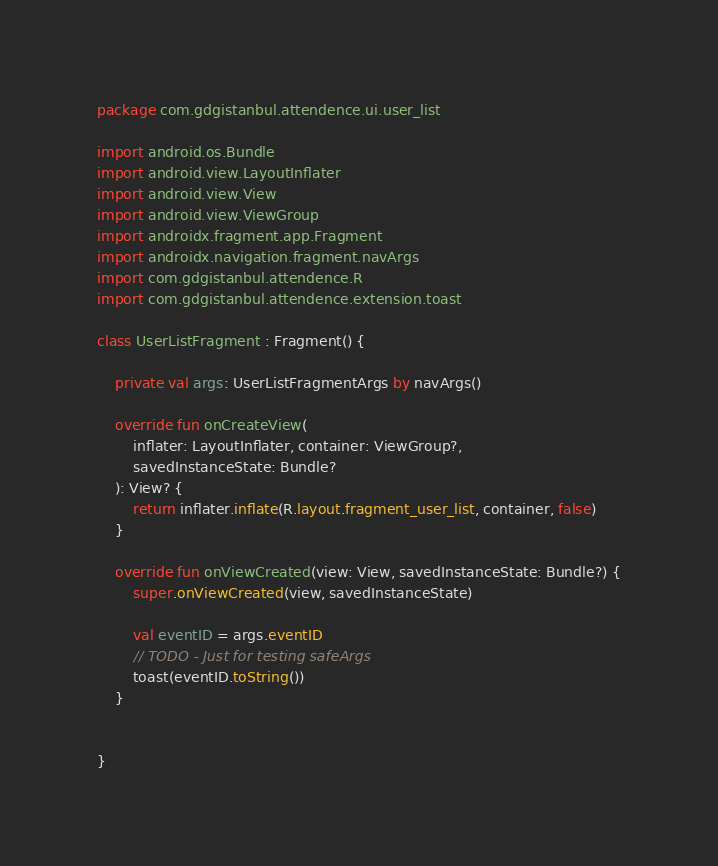Convert code to text. <code><loc_0><loc_0><loc_500><loc_500><_Kotlin_>package com.gdgistanbul.attendence.ui.user_list

import android.os.Bundle
import android.view.LayoutInflater
import android.view.View
import android.view.ViewGroup
import androidx.fragment.app.Fragment
import androidx.navigation.fragment.navArgs
import com.gdgistanbul.attendence.R
import com.gdgistanbul.attendence.extension.toast

class UserListFragment : Fragment() {

    private val args: UserListFragmentArgs by navArgs()

    override fun onCreateView(
        inflater: LayoutInflater, container: ViewGroup?,
        savedInstanceState: Bundle?
    ): View? {
        return inflater.inflate(R.layout.fragment_user_list, container, false)
    }

    override fun onViewCreated(view: View, savedInstanceState: Bundle?) {
        super.onViewCreated(view, savedInstanceState)

        val eventID = args.eventID
        // TODO - Just for testing safeArgs
        toast(eventID.toString())
    }


}
</code> 